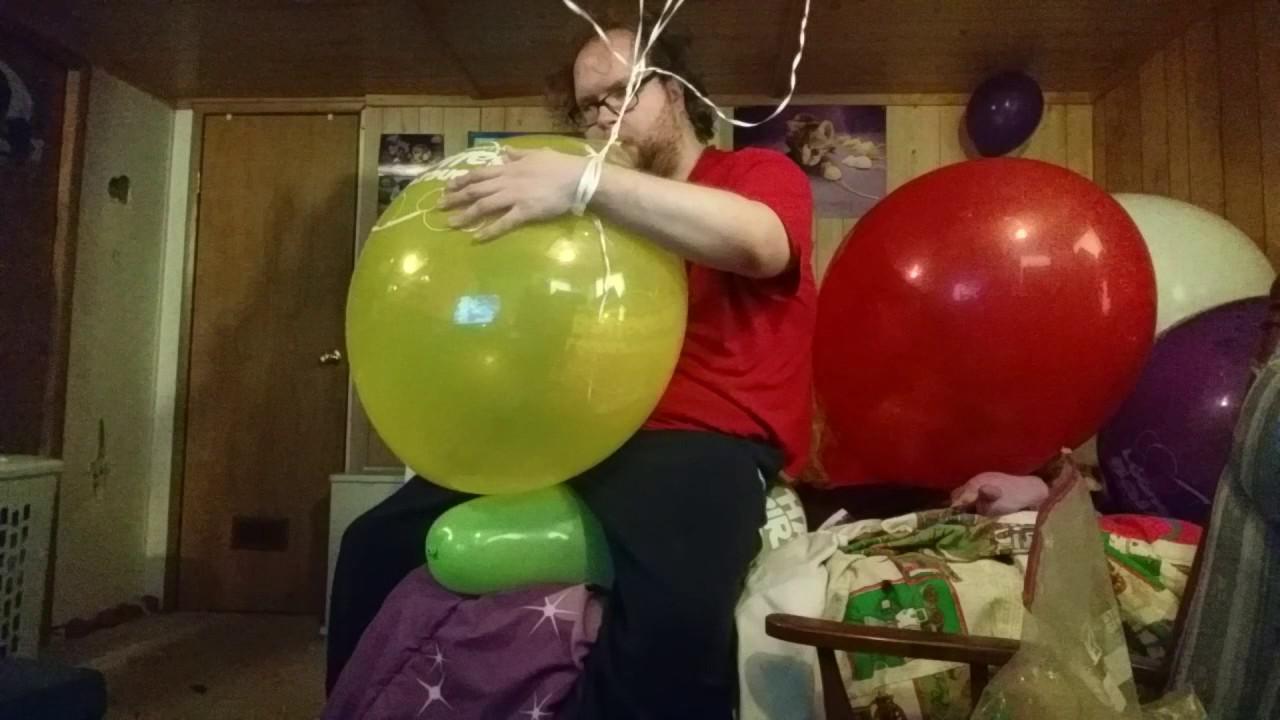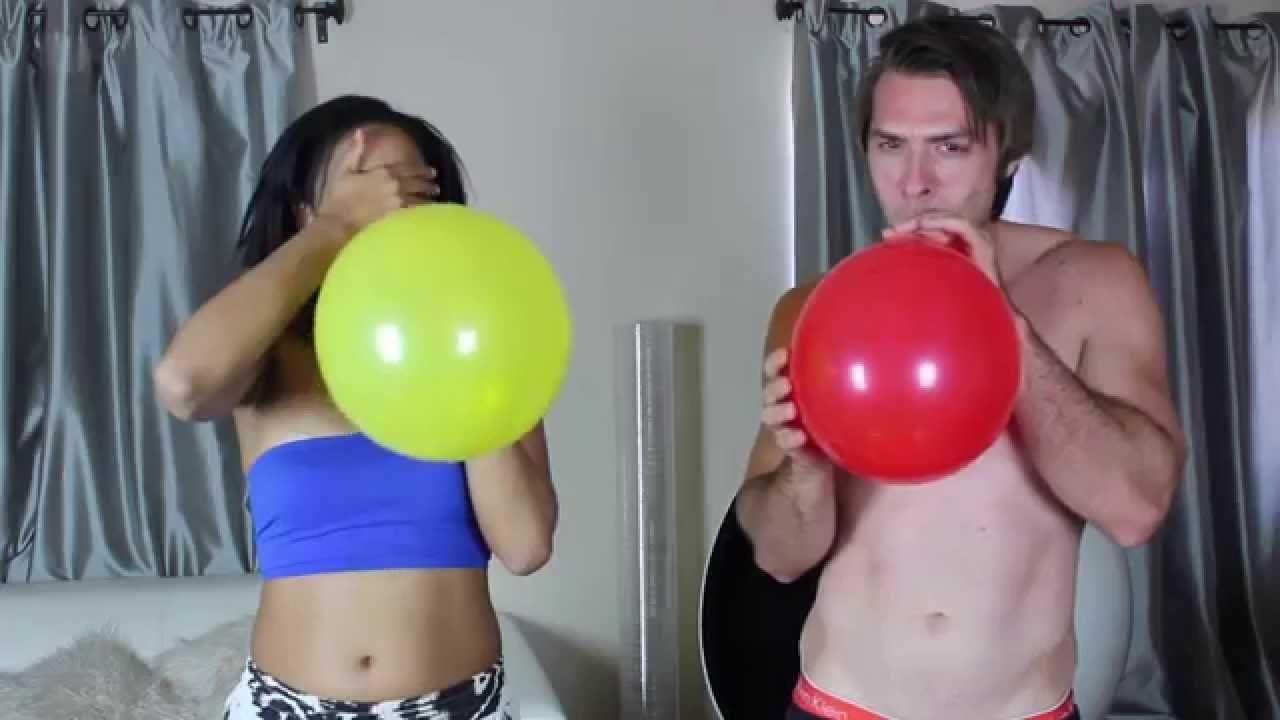The first image is the image on the left, the second image is the image on the right. For the images displayed, is the sentence "Someone is blowing up a balloon in the right image." factually correct? Answer yes or no. Yes. The first image is the image on the left, the second image is the image on the right. Evaluate the accuracy of this statement regarding the images: "There is at least one image with a man blowing up a yellow balloon.". Is it true? Answer yes or no. Yes. 